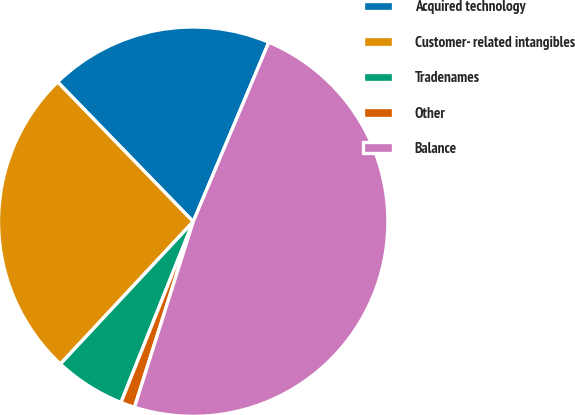<chart> <loc_0><loc_0><loc_500><loc_500><pie_chart><fcel>Acquired technology<fcel>Customer- related intangibles<fcel>Tradenames<fcel>Other<fcel>Balance<nl><fcel>18.61%<fcel>25.79%<fcel>5.9%<fcel>1.17%<fcel>48.53%<nl></chart> 